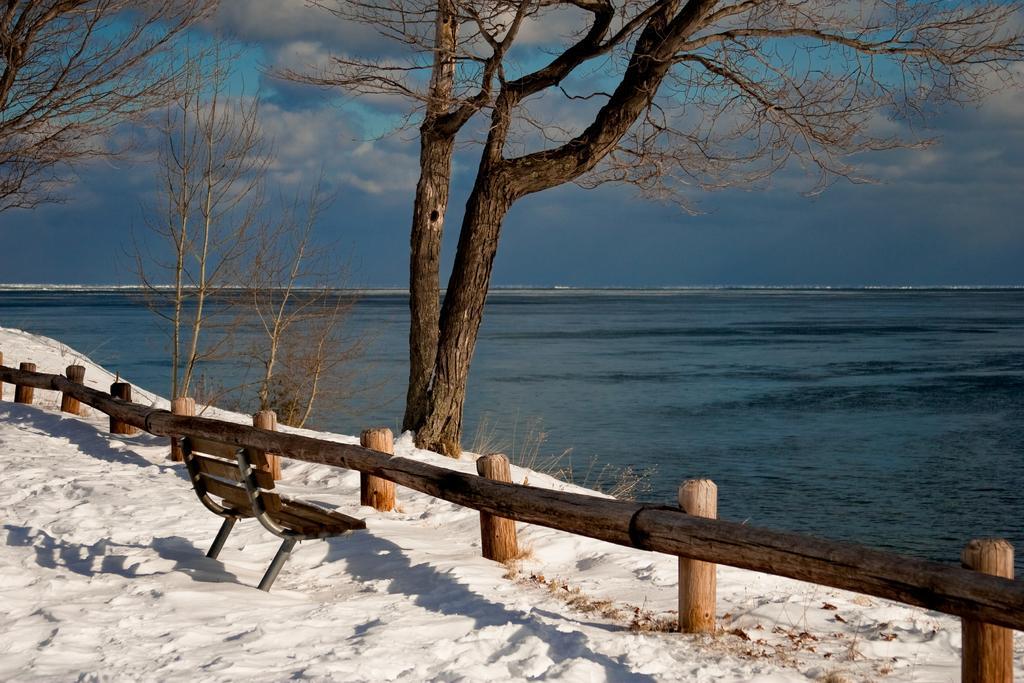Please provide a concise description of this image. In the image there is a bench in front of fence on snow land and in the back there is sea and above its sky with clouds. 